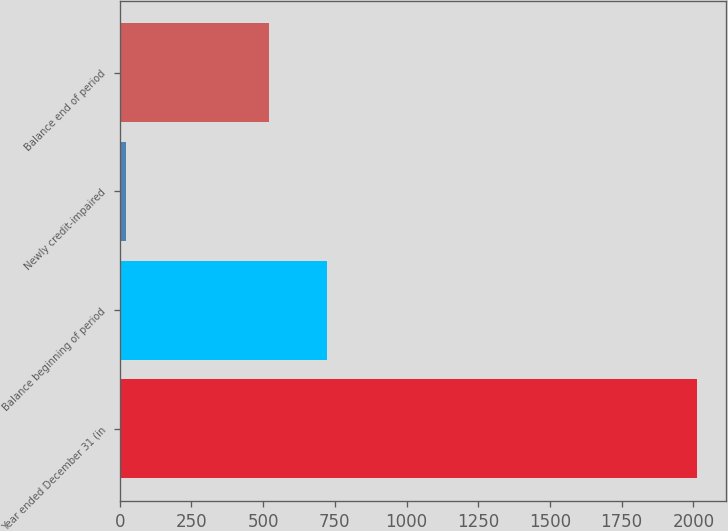Convert chart to OTSL. <chart><loc_0><loc_0><loc_500><loc_500><bar_chart><fcel>Year ended December 31 (in<fcel>Balance beginning of period<fcel>Newly credit-impaired<fcel>Balance end of period<nl><fcel>2012<fcel>721.1<fcel>21<fcel>522<nl></chart> 